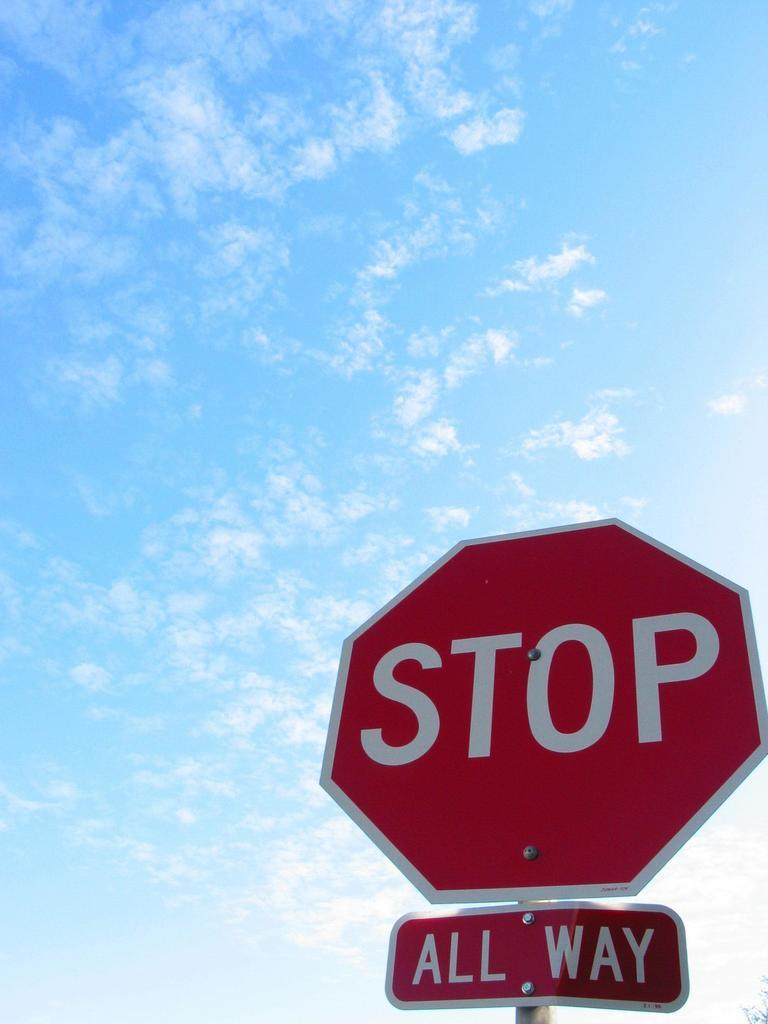<image>
Describe the image concisely. The sign below the stop sign indicates that this is an all way stop. 